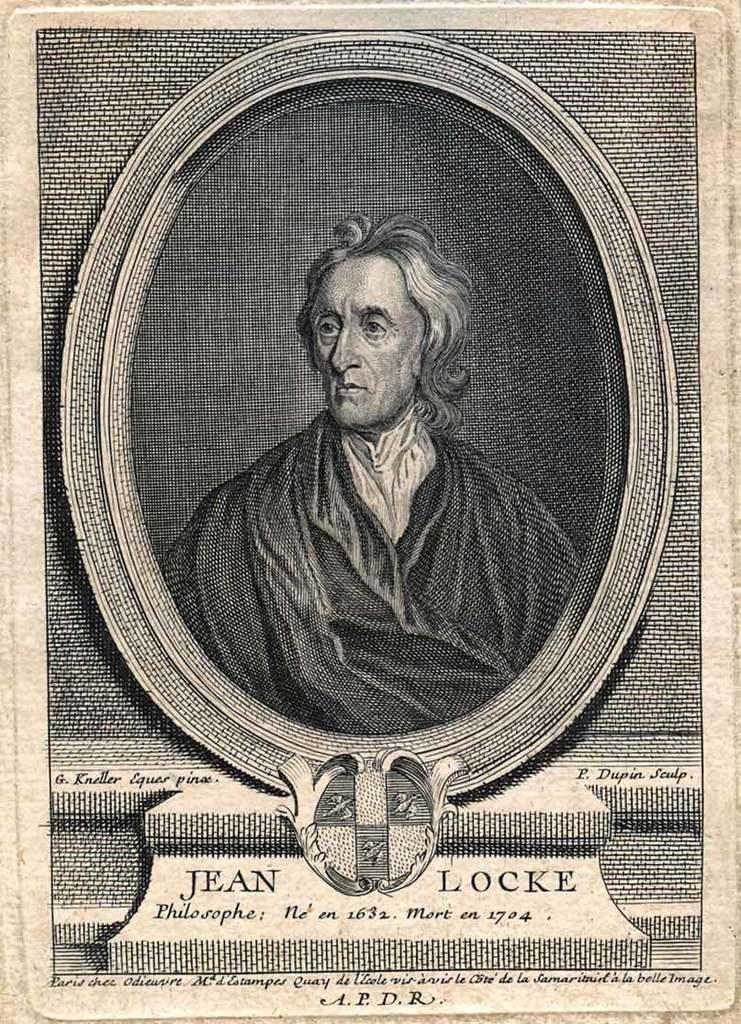<image>
Relay a brief, clear account of the picture shown. An old Jean Locke portrait done in pen and ink. 